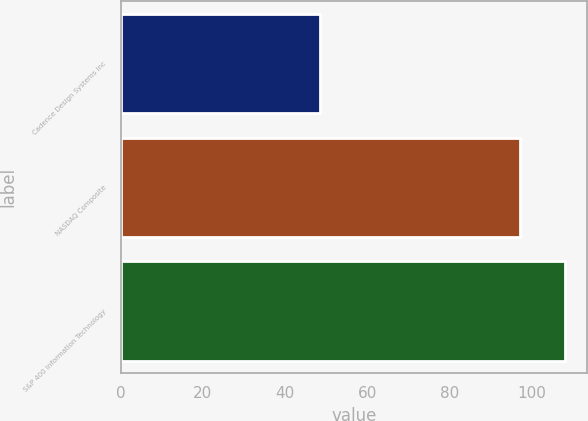<chart> <loc_0><loc_0><loc_500><loc_500><bar_chart><fcel>Cadence Design Systems Inc<fcel>NASDAQ Composite<fcel>S&P 400 Information Technology<nl><fcel>48.5<fcel>97.32<fcel>108.11<nl></chart> 